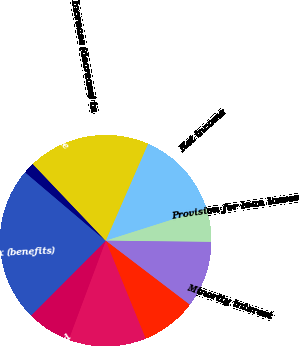Convert chart to OTSL. <chart><loc_0><loc_0><loc_500><loc_500><pie_chart><fcel>Net income<fcel>Provision for loan losses<fcel>Minority interest<fcel>Depreciation and amortization<fcel>Net loss on sales of<fcel>Net gains on disposition of<fcel>(Increase) decrease in accrued<fcel>Deferred income tax (benefits)<fcel>(Increase) decrease in income<fcel>Increase (decrease) in<nl><fcel>13.56%<fcel>5.08%<fcel>10.17%<fcel>8.47%<fcel>11.86%<fcel>6.78%<fcel>0.0%<fcel>23.73%<fcel>1.7%<fcel>18.64%<nl></chart> 